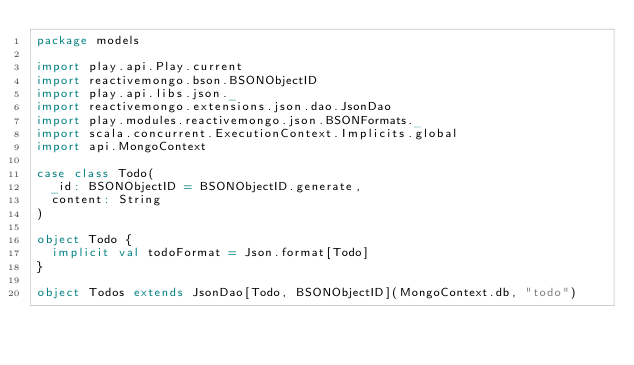<code> <loc_0><loc_0><loc_500><loc_500><_Scala_>package models

import play.api.Play.current
import reactivemongo.bson.BSONObjectID
import play.api.libs.json._
import reactivemongo.extensions.json.dao.JsonDao
import play.modules.reactivemongo.json.BSONFormats._
import scala.concurrent.ExecutionContext.Implicits.global
import api.MongoContext

case class Todo(
  _id: BSONObjectID = BSONObjectID.generate,
  content: String
)

object Todo {
  implicit val todoFormat = Json.format[Todo]
}

object Todos extends JsonDao[Todo, BSONObjectID](MongoContext.db, "todo")</code> 